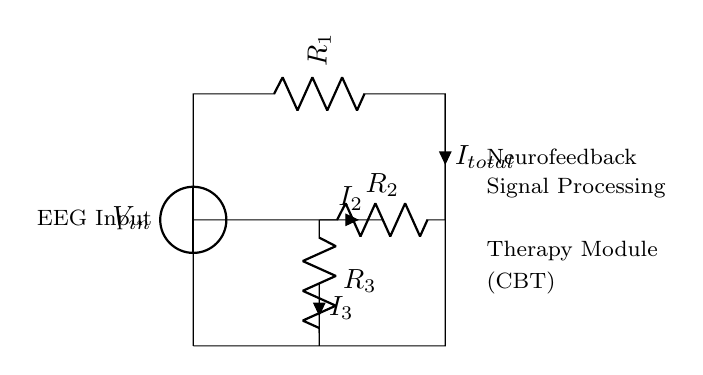What is the input voltage represented in the circuit? The input voltage is labeled as V_in, indicating the source voltage feeding the circuit.
Answer: V_in What are the values of R2 and R3 in the circuit? The values of R2 and R3 are shown adjacent to their symbols; however, the exact numerical values are not provided in the diagram, so we cannot directly answer.
Answer: Not specified How many branches does the circuit create? The circuit branches into three paths: one through R2, one through R3, and one as the main output through R1.
Answer: Three What is the total current denoted in the circuit? The total current flowing into the circuit is labeled as I_total at the connection node of R1.
Answer: I_total How do currents I2 and I3 relate to the total current I_total? I2 and I3 are currents flowing through the branches R2 and R3, respectively. The relationship follows the current divider rule, where I_total equals the sum of I2 and I3.
Answer: I_total = I2 + I3 What does the signal processing module indicate in the circuit? The signal processing module is indicated by the labeled section, suggesting it plays a role in analyzing and managing the data received from the EEG input through the circuit branches.
Answer: Neurofeedback Signal Processing Which component operates within the therapy module for cognitive behavioral therapy? R3 is identified as part of the therapy module specifically noted for its connection to cognitive behavioral therapy (CBT) in the design.
Answer: R3 